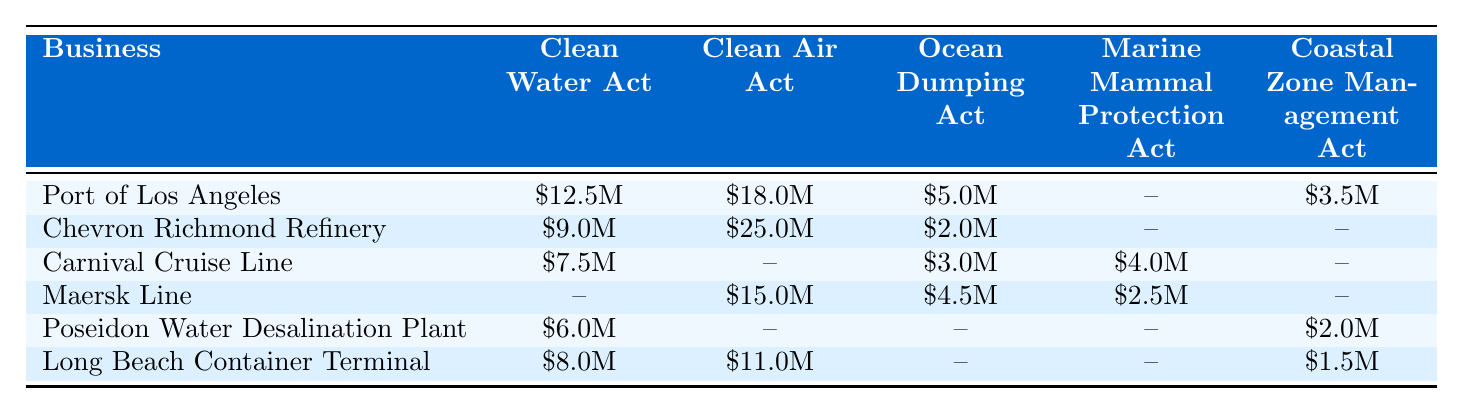What is the highest compliance cost for the Clean Air Act among the businesses? The businesses listed under the Clean Air Act and their compliance costs are: Chevron Richmond Refinery at $25 million, Maersk Line at $15 million, and Long Beach Container Terminal at $11 million. The highest is Chevron Richmond Refinery at $25 million.
Answer: $25 million Which business has the lowest compliance cost under the Ocean Dumping Act? The businesses with compliance costs under the Ocean Dumping Act are: Port of Los Angeles at $5 million, Chevron Richmond Refinery at $2 million, Carnival Cruise Line at $3 million, Maersk Line at $4.5 million. The lowest cost is from Chevron Richmond Refinery at $2 million.
Answer: $2 million Are there any businesses that have no compliance costs for the Marine Mammal Protection Act? The businesses listed with no cost for the Marine Mammal Protection Act are: Port of Los Angeles, Chevron Richmond Refinery, Poseidon Water Desalination Plant, and Long Beach Container Terminal, which confirms that there are four such businesses.
Answer: Yes What is the total compliance cost for the Port of Los Angeles across all regulations? The Port of Los Angeles has the following costs: Clean Water Act at $12.5 million, Clean Air Act at $18 million, Ocean Dumping Act at $5 million, and Coastal Zone Management Act at $3.5 million. Summing these costs gives $12.5M + $18.0M + $5.0M + $3.5M = $39 million.
Answer: $39 million Which business has the highest total compliance costs among all regulations? To find the total compliance costs for each business, we sum their respective costs: Port of Los Angeles: $39M, Chevron Richmond Refinery: $36M, Carnival Cruise Line: $14.5M, Maersk Line: $22M, Poseidon Water: $8M, Long Beach: $20.5M. The highest total is for Port of Los Angeles at $39 million.
Answer: Port of Los Angeles How many businesses have compliance costs associated with the Clean Water Act? The businesses with compliance costs for the Clean Water Act are: Port of Los Angeles, Chevron Richmond Refinery, Carnival Cruise Line, Poseidon Water, and Long Beach Container Terminal. This totals to five businesses.
Answer: 5 What is the combined compliance cost for the Clean Water Act among all the businesses? Adding the compliance costs for the Clean Water Act: $12.5M (Port of Los Angeles) + $9M (Chevron Richmond Refinery) + $7.5M (Carnival Cruise Line) + $6M (Poseidon Water) + $8M (Long Beach) gives a total of $43 million.
Answer: $43 million Does any business have a compliance cost associated with the Coastal Zone Management Act? The businesses with costs under the Coastal Zone Management Act are: Port of Los Angeles at $3.5 million, Poseidon Water at $2 million, and Long Beach Container Terminal at $1.5 million. Therefore, there are businesses with associated costs.
Answer: Yes Which regulation has the highest average compliance cost across all the businesses? The compliance costs for each regulation are: Clean Water Act = ($12.5M + $9M + $7.5M + $6M + $8M) = $43M, Clean Air Act = ($18M + $25M + $15M + $11M) = $69M, Ocean Dumping Act = ($5M + $2M + $3M + $4.5M) = $14.5M, Marine Mammal Protection Act = ($4M + $2.5M) = $6.5M, Coastal Zone Management Act = ($3.5M + $2M + $1.5M) = $7M. The highest average would be Clean Air Act with an average of $17.25 million per business involved.
Answer: Clean Air Act What is the total compliance cost for the Marine Mammal Protection Act in the table? The businesses with costs for the Marine Mammal Protection Act are: Carnival Cruise Line for $4 million and Maersk Line for $2.5 million. Totaling these costs gives $4M + $2.5M = $6.5 million.
Answer: $6.5 million 